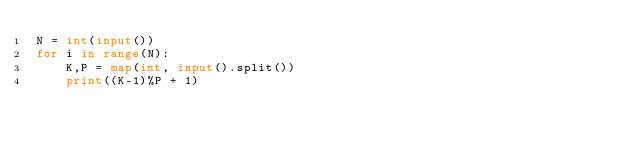<code> <loc_0><loc_0><loc_500><loc_500><_Python_>N = int(input())
for i in range(N):
    K,P = map(int, input().split())
    print((K-1)%P + 1)
</code> 